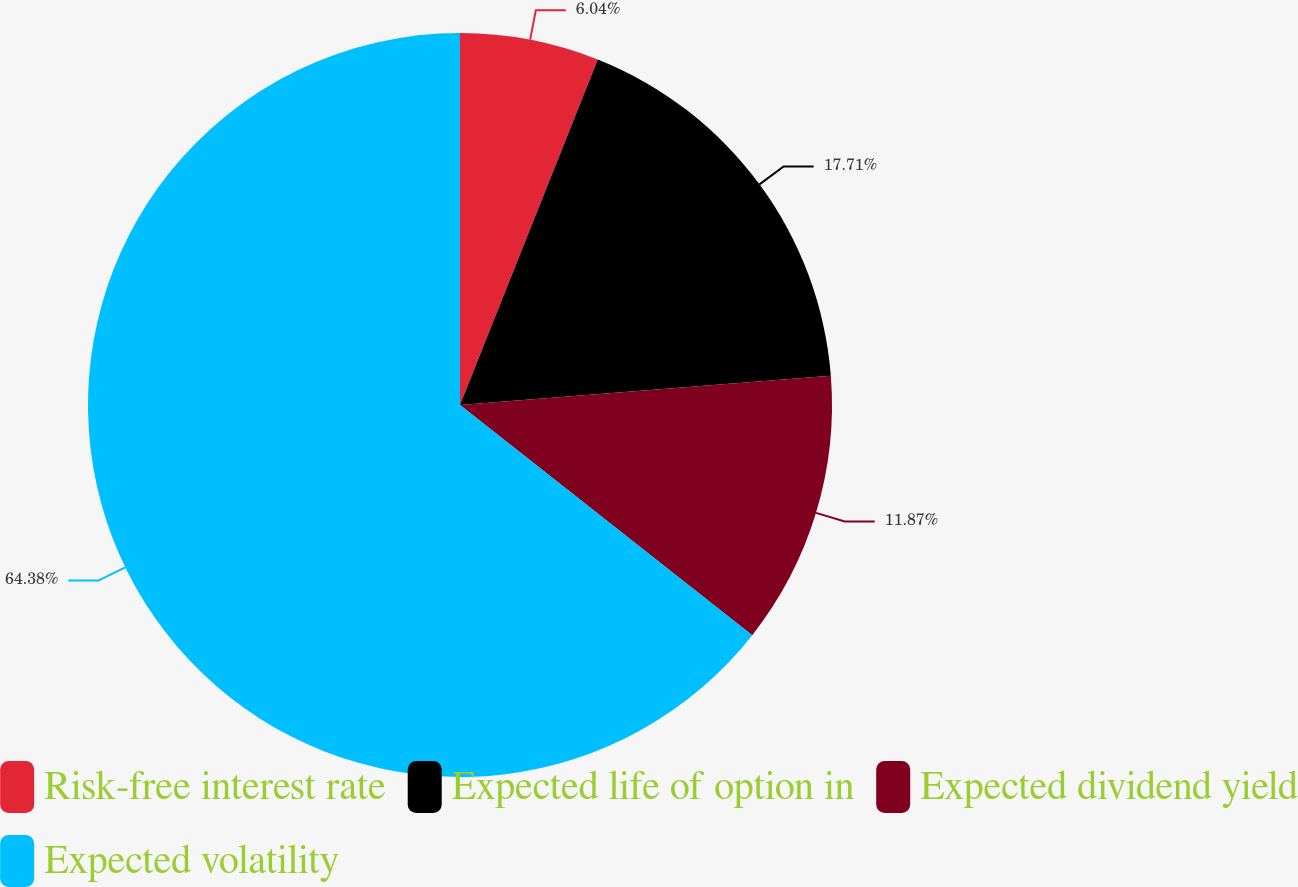Convert chart to OTSL. <chart><loc_0><loc_0><loc_500><loc_500><pie_chart><fcel>Risk-free interest rate<fcel>Expected life of option in<fcel>Expected dividend yield<fcel>Expected volatility<nl><fcel>6.04%<fcel>17.71%<fcel>11.87%<fcel>64.39%<nl></chart> 